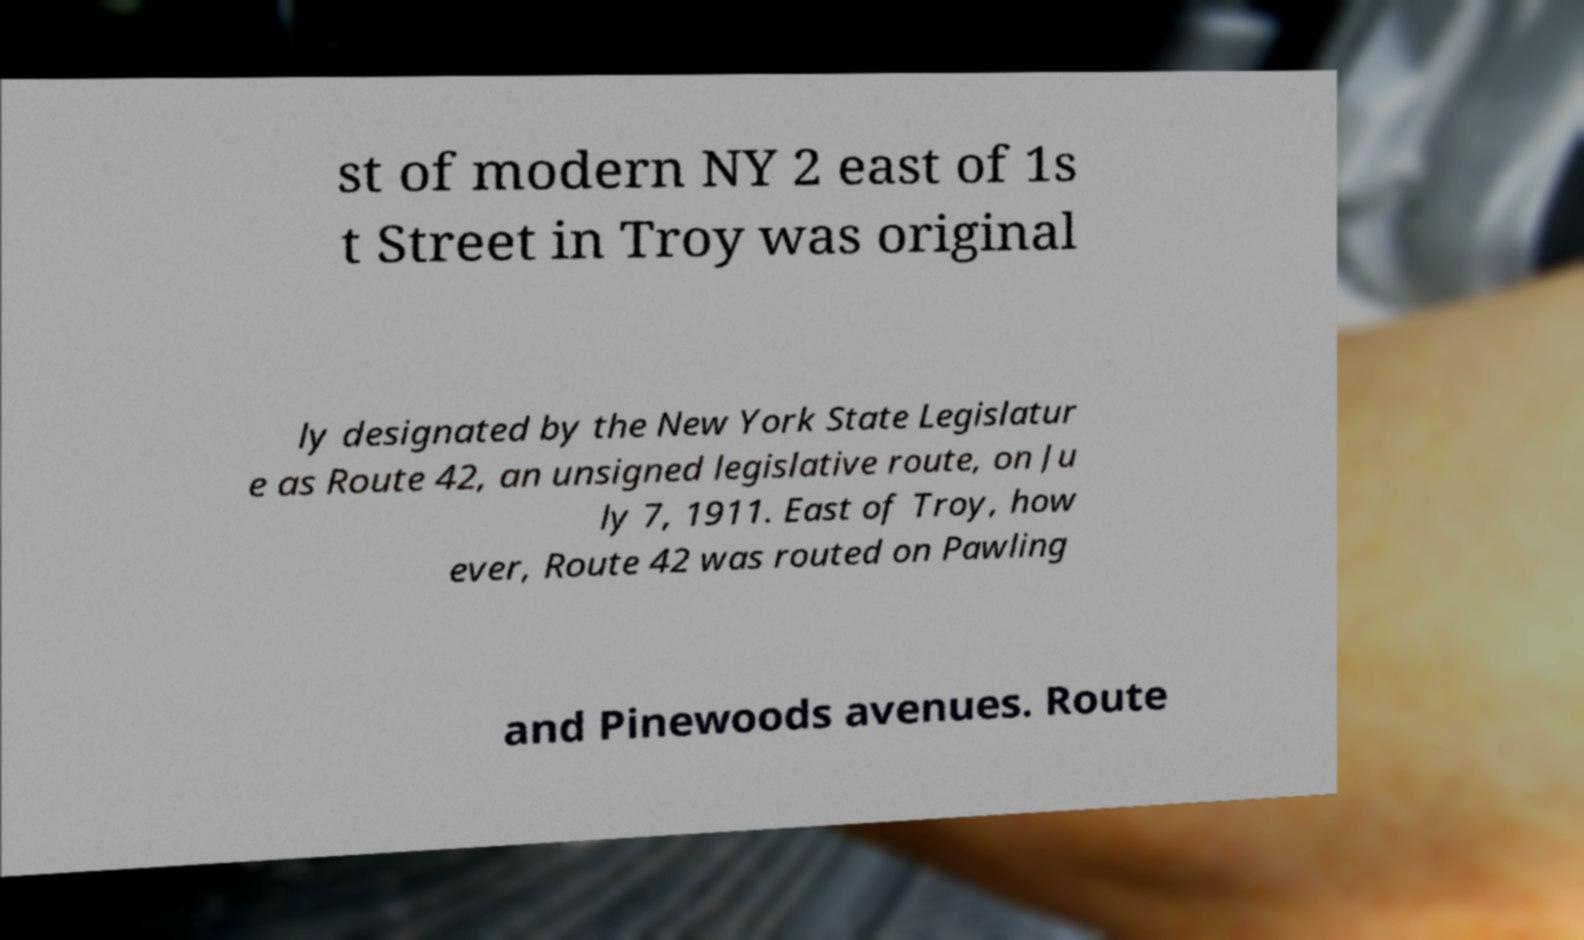Please identify and transcribe the text found in this image. st of modern NY 2 east of 1s t Street in Troy was original ly designated by the New York State Legislatur e as Route 42, an unsigned legislative route, on Ju ly 7, 1911. East of Troy, how ever, Route 42 was routed on Pawling and Pinewoods avenues. Route 